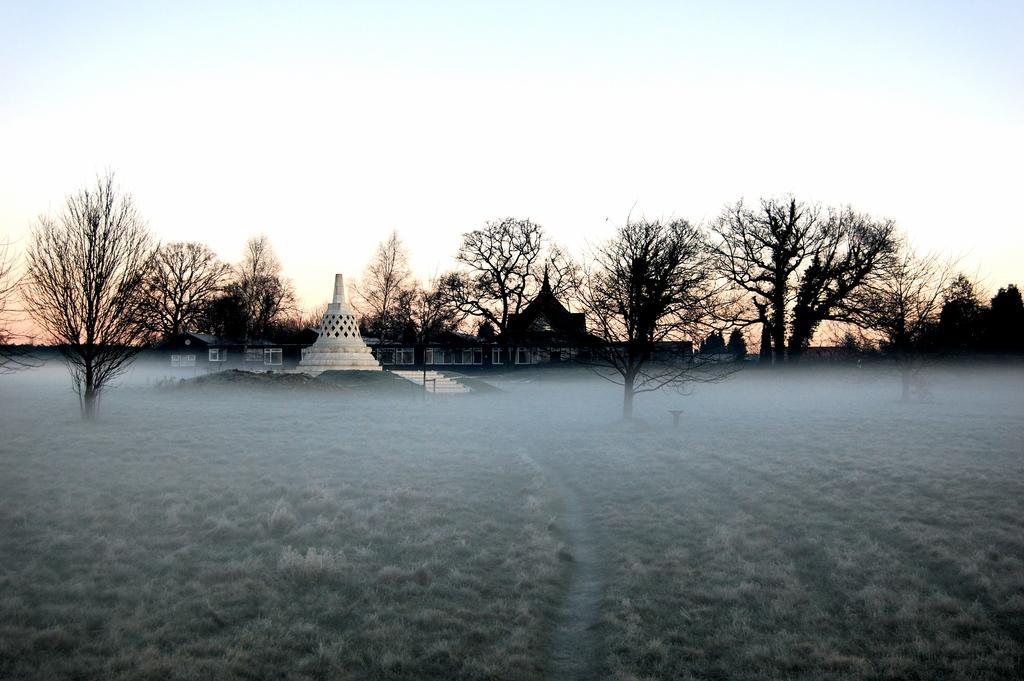Can you describe this image briefly? In this picture we can see trees and ancient architecture. This is ground. In the background there is sky. 